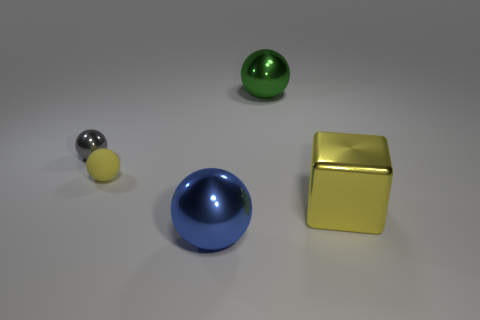Which object stands out the most and why? The object that stands out the most is the matte yellow cube due to its geometric shape contrasting with the other round objects and its vibrant, solid color that differentiates it from the more subdued tones of the other items. 